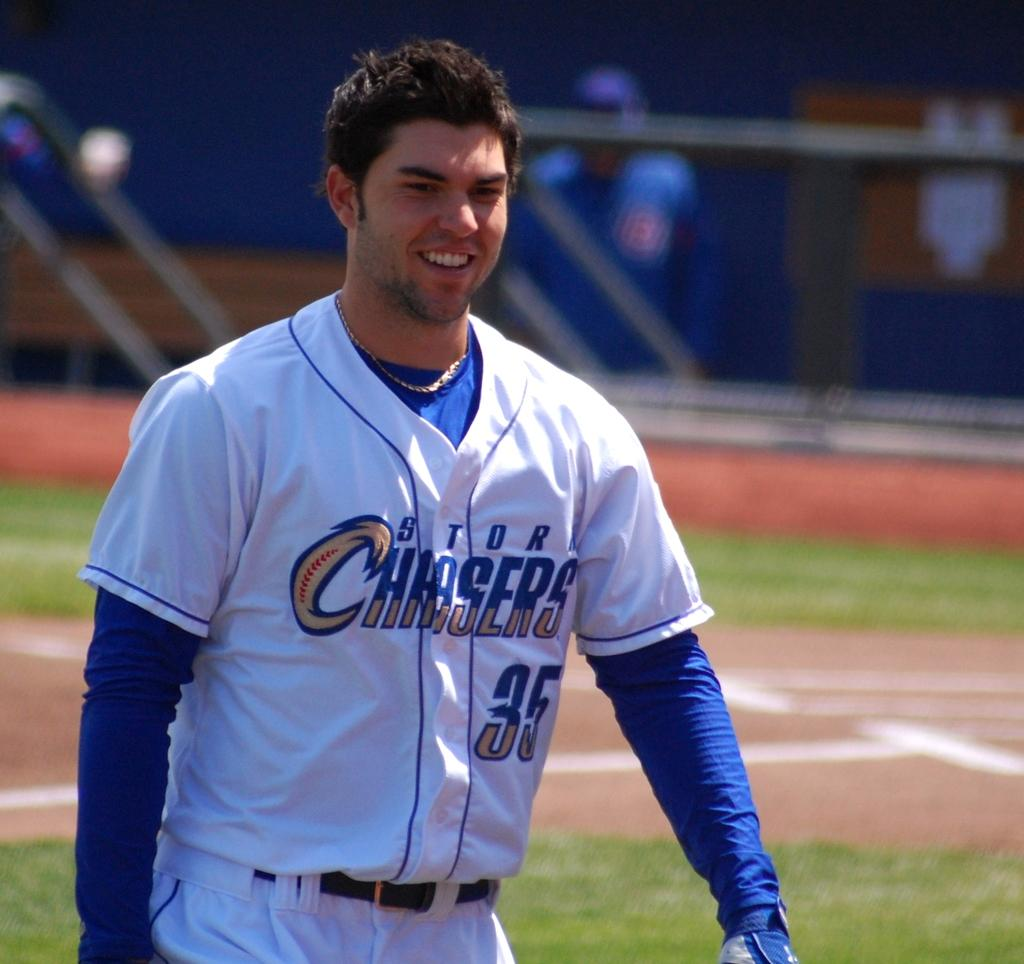<image>
Offer a succinct explanation of the picture presented. a smiling baseball player with STORM CHASERS 35 in his jersey. 